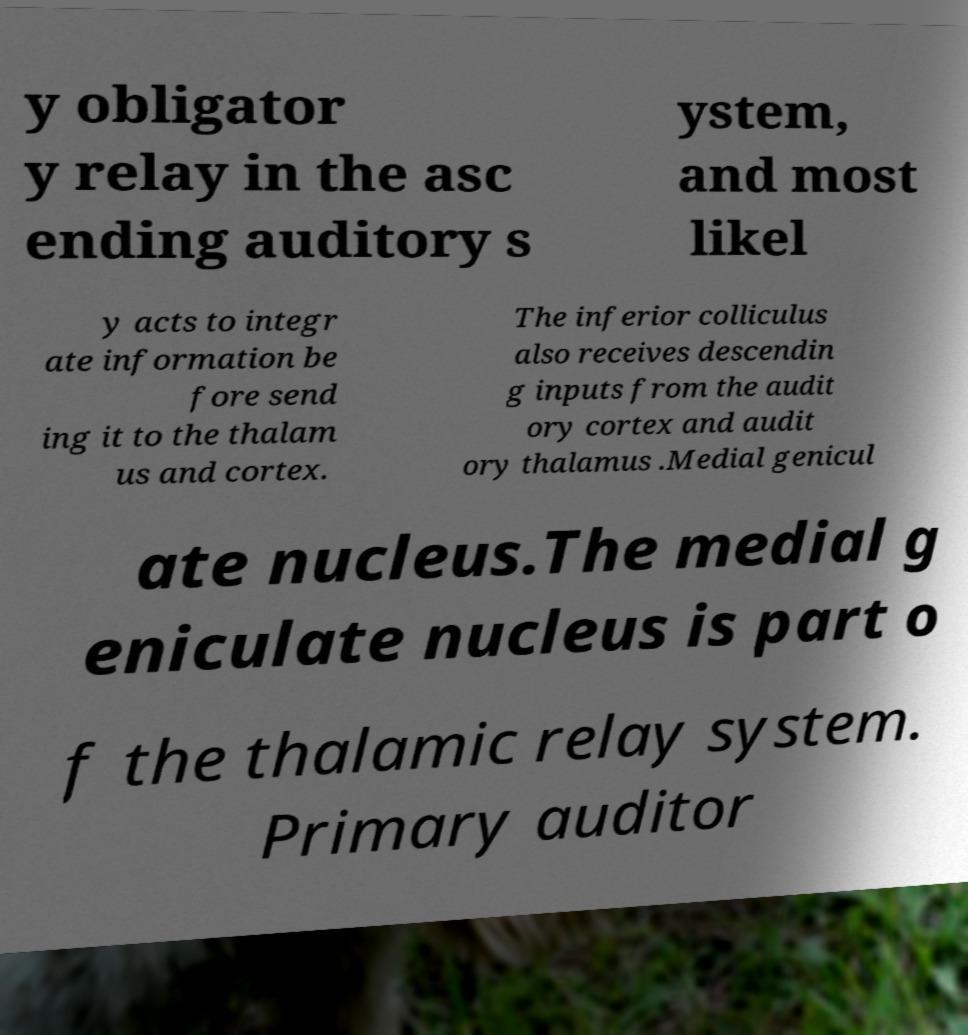Could you extract and type out the text from this image? y obligator y relay in the asc ending auditory s ystem, and most likel y acts to integr ate information be fore send ing it to the thalam us and cortex. The inferior colliculus also receives descendin g inputs from the audit ory cortex and audit ory thalamus .Medial genicul ate nucleus.The medial g eniculate nucleus is part o f the thalamic relay system. Primary auditor 